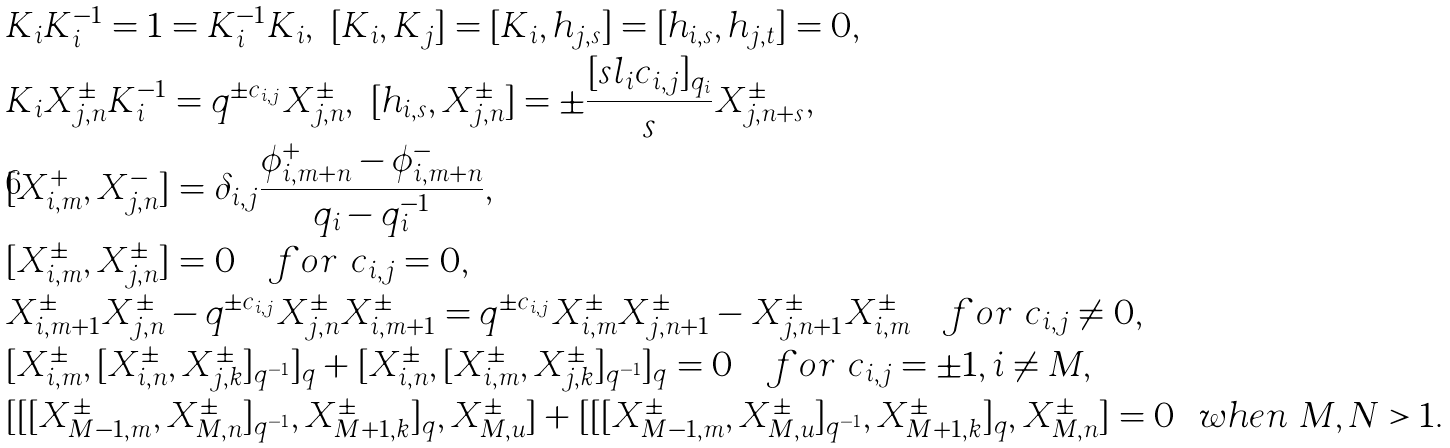Convert formula to latex. <formula><loc_0><loc_0><loc_500><loc_500>& K _ { i } K _ { i } ^ { - 1 } = 1 = K _ { i } ^ { - 1 } K _ { i } , \ [ K _ { i } , K _ { j } ] = [ K _ { i } , h _ { j , s } ] = [ h _ { i , s } , h _ { j , t } ] = 0 , \\ & K _ { i } X _ { j , n } ^ { \pm } K _ { i } ^ { - 1 } = q ^ { \pm c _ { i , j } } X _ { j , n } ^ { \pm } , \ [ h _ { i , s } , X _ { j , n } ^ { \pm } ] = \pm \frac { [ s l _ { i } c _ { i , j } ] _ { q _ { i } } } { s } X _ { j , n + s } ^ { \pm } , \\ & [ X _ { i , m } ^ { + } , X _ { j , n } ^ { - } ] = \delta _ { i , j } \frac { \phi _ { i , m + n } ^ { + } - \phi _ { i , m + n } ^ { - } } { q _ { i } - q _ { i } ^ { - 1 } } , \\ & [ X _ { i , m } ^ { \pm } , X _ { j , n } ^ { \pm } ] = 0 \quad f o r \ c _ { i , j } = 0 , \\ & X _ { i , m + 1 } ^ { \pm } X _ { j , n } ^ { \pm } - q ^ { \pm c _ { i , j } } X _ { j , n } ^ { \pm } X _ { i , m + 1 } ^ { \pm } = q ^ { \pm c _ { i , j } } X _ { i , m } ^ { \pm } X _ { j , n + 1 } ^ { \pm } - X _ { j , n + 1 } ^ { \pm } X _ { i , m } ^ { \pm } \quad f o r \ c _ { i , j } \neq 0 , \\ & [ X _ { i , m } ^ { \pm } , [ X _ { i , n } ^ { \pm } , X _ { j , k } ^ { \pm } ] _ { q ^ { - 1 } } ] _ { q } + [ X _ { i , n } ^ { \pm } , [ X _ { i , m } ^ { \pm } , X _ { j , k } ^ { \pm } ] _ { q ^ { - 1 } } ] _ { q } = 0 \quad f o r \ c _ { i , j } = \pm 1 , i \neq M , \\ & [ [ [ X _ { M - 1 , m } ^ { \pm } , X _ { M , n } ^ { \pm } ] _ { q ^ { - 1 } } , X _ { M + 1 , k } ^ { \pm } ] _ { q } , X _ { M , u } ^ { \pm } ] + [ [ [ X _ { M - 1 , m } ^ { \pm } , X _ { M , u } ^ { \pm } ] _ { q ^ { - 1 } } , X _ { M + 1 , k } ^ { \pm } ] _ { q } , X _ { M , n } ^ { \pm } ] = 0 \ \ w h e n \ M , N > 1 .</formula> 